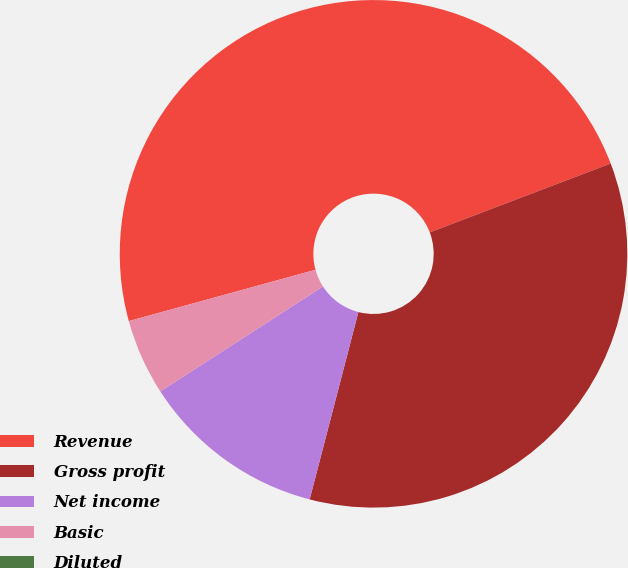Convert chart. <chart><loc_0><loc_0><loc_500><loc_500><pie_chart><fcel>Revenue<fcel>Gross profit<fcel>Net income<fcel>Basic<fcel>Diluted<nl><fcel>48.48%<fcel>34.84%<fcel>11.83%<fcel>4.85%<fcel>0.0%<nl></chart> 